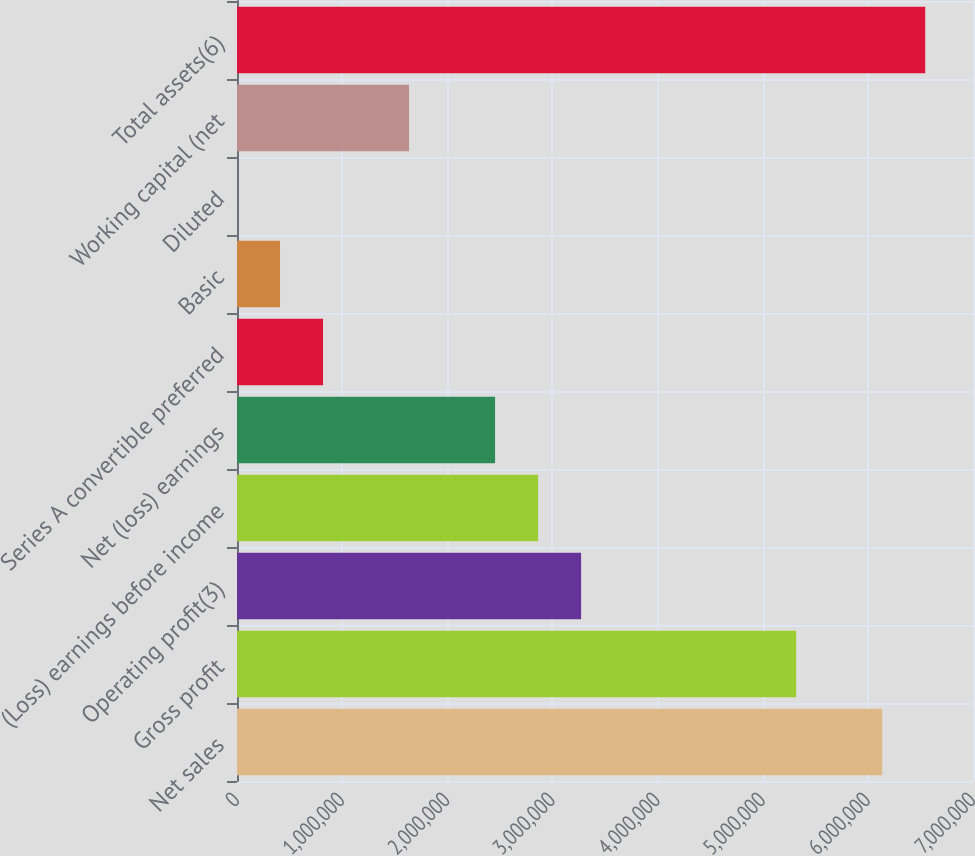<chart> <loc_0><loc_0><loc_500><loc_500><bar_chart><fcel>Net sales<fcel>Gross profit<fcel>Operating profit(3)<fcel>(Loss) earnings before income<fcel>Net (loss) earnings<fcel>Series A convertible preferred<fcel>Basic<fcel>Diluted<fcel>Working capital (net<fcel>Total assets(6)<nl><fcel>6.13632e+06<fcel>5.31815e+06<fcel>3.27271e+06<fcel>2.86362e+06<fcel>2.45453e+06<fcel>818178<fcel>409090<fcel>1.93<fcel>1.63635e+06<fcel>6.54541e+06<nl></chart> 